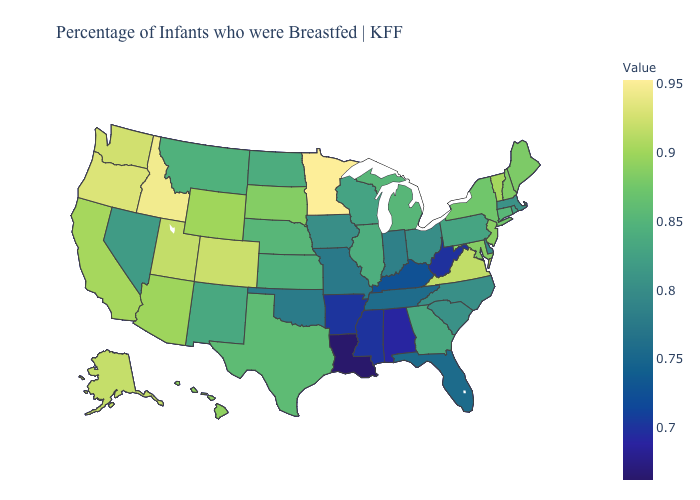Does Virginia have the highest value in the South?
Answer briefly. Yes. Does Pennsylvania have the lowest value in the USA?
Give a very brief answer. No. Which states have the lowest value in the South?
Answer briefly. Louisiana. Which states have the lowest value in the USA?
Short answer required. Louisiana. Does Minnesota have the highest value in the MidWest?
Be succinct. Yes. Does Minnesota have the highest value in the MidWest?
Be succinct. Yes. Does Washington have the highest value in the USA?
Quick response, please. No. Does Colorado have the lowest value in the West?
Be succinct. No. 